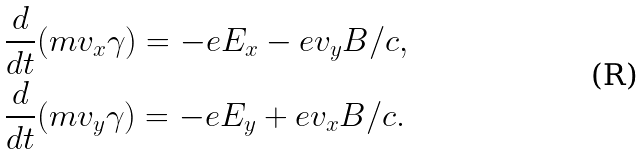Convert formula to latex. <formula><loc_0><loc_0><loc_500><loc_500>& \frac { d } { d t } ( m v _ { x } \gamma ) = - e E _ { x } - e v _ { y } B / c , \\ & \frac { d } { d t } ( m v _ { y } \gamma ) = - e E _ { y } + e v _ { x } B / c .</formula> 